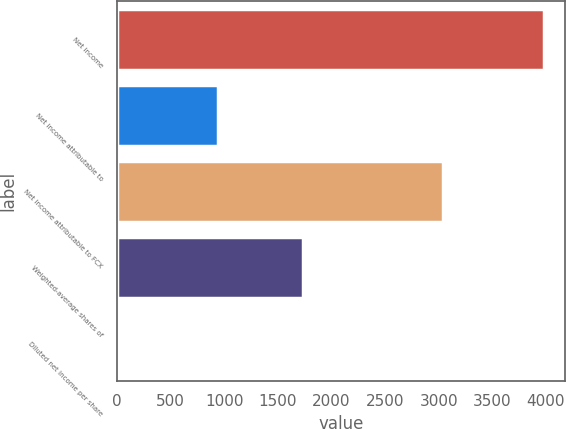Convert chart. <chart><loc_0><loc_0><loc_500><loc_500><bar_chart><fcel>Net income<fcel>Net income attributable to<fcel>Net income attributable to FCX<fcel>Weighted-average shares of<fcel>Diluted net income per share<nl><fcel>3980<fcel>939<fcel>3041<fcel>1734.36<fcel>3.19<nl></chart> 